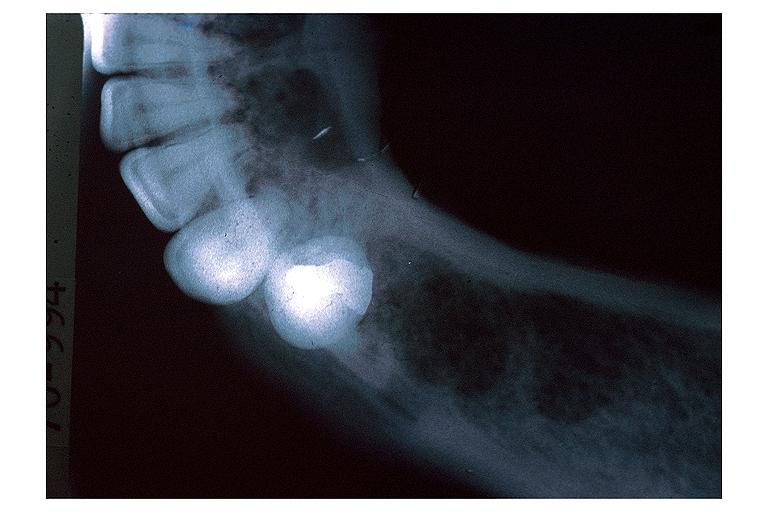s carcinomatous meningitis present?
Answer the question using a single word or phrase. No 